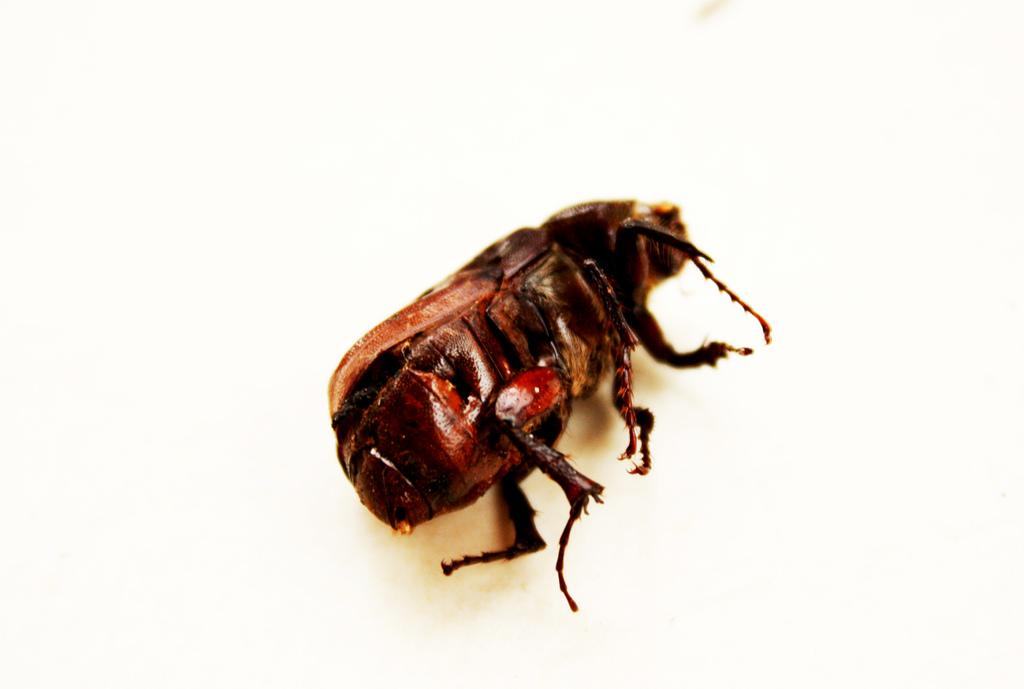What type of creature is present in the image? There is an insect in the image. What is the insect doing in the image? The insect is lying. What color is the background of the image? The background of the image is white. What type of book is the insect reading in the image? There is no book present in the image, as it features an insect lying on a white background. What kind of behavior is the insect exhibiting in the image? The insect is simply lying in the image, and no specific behavior is evident. 